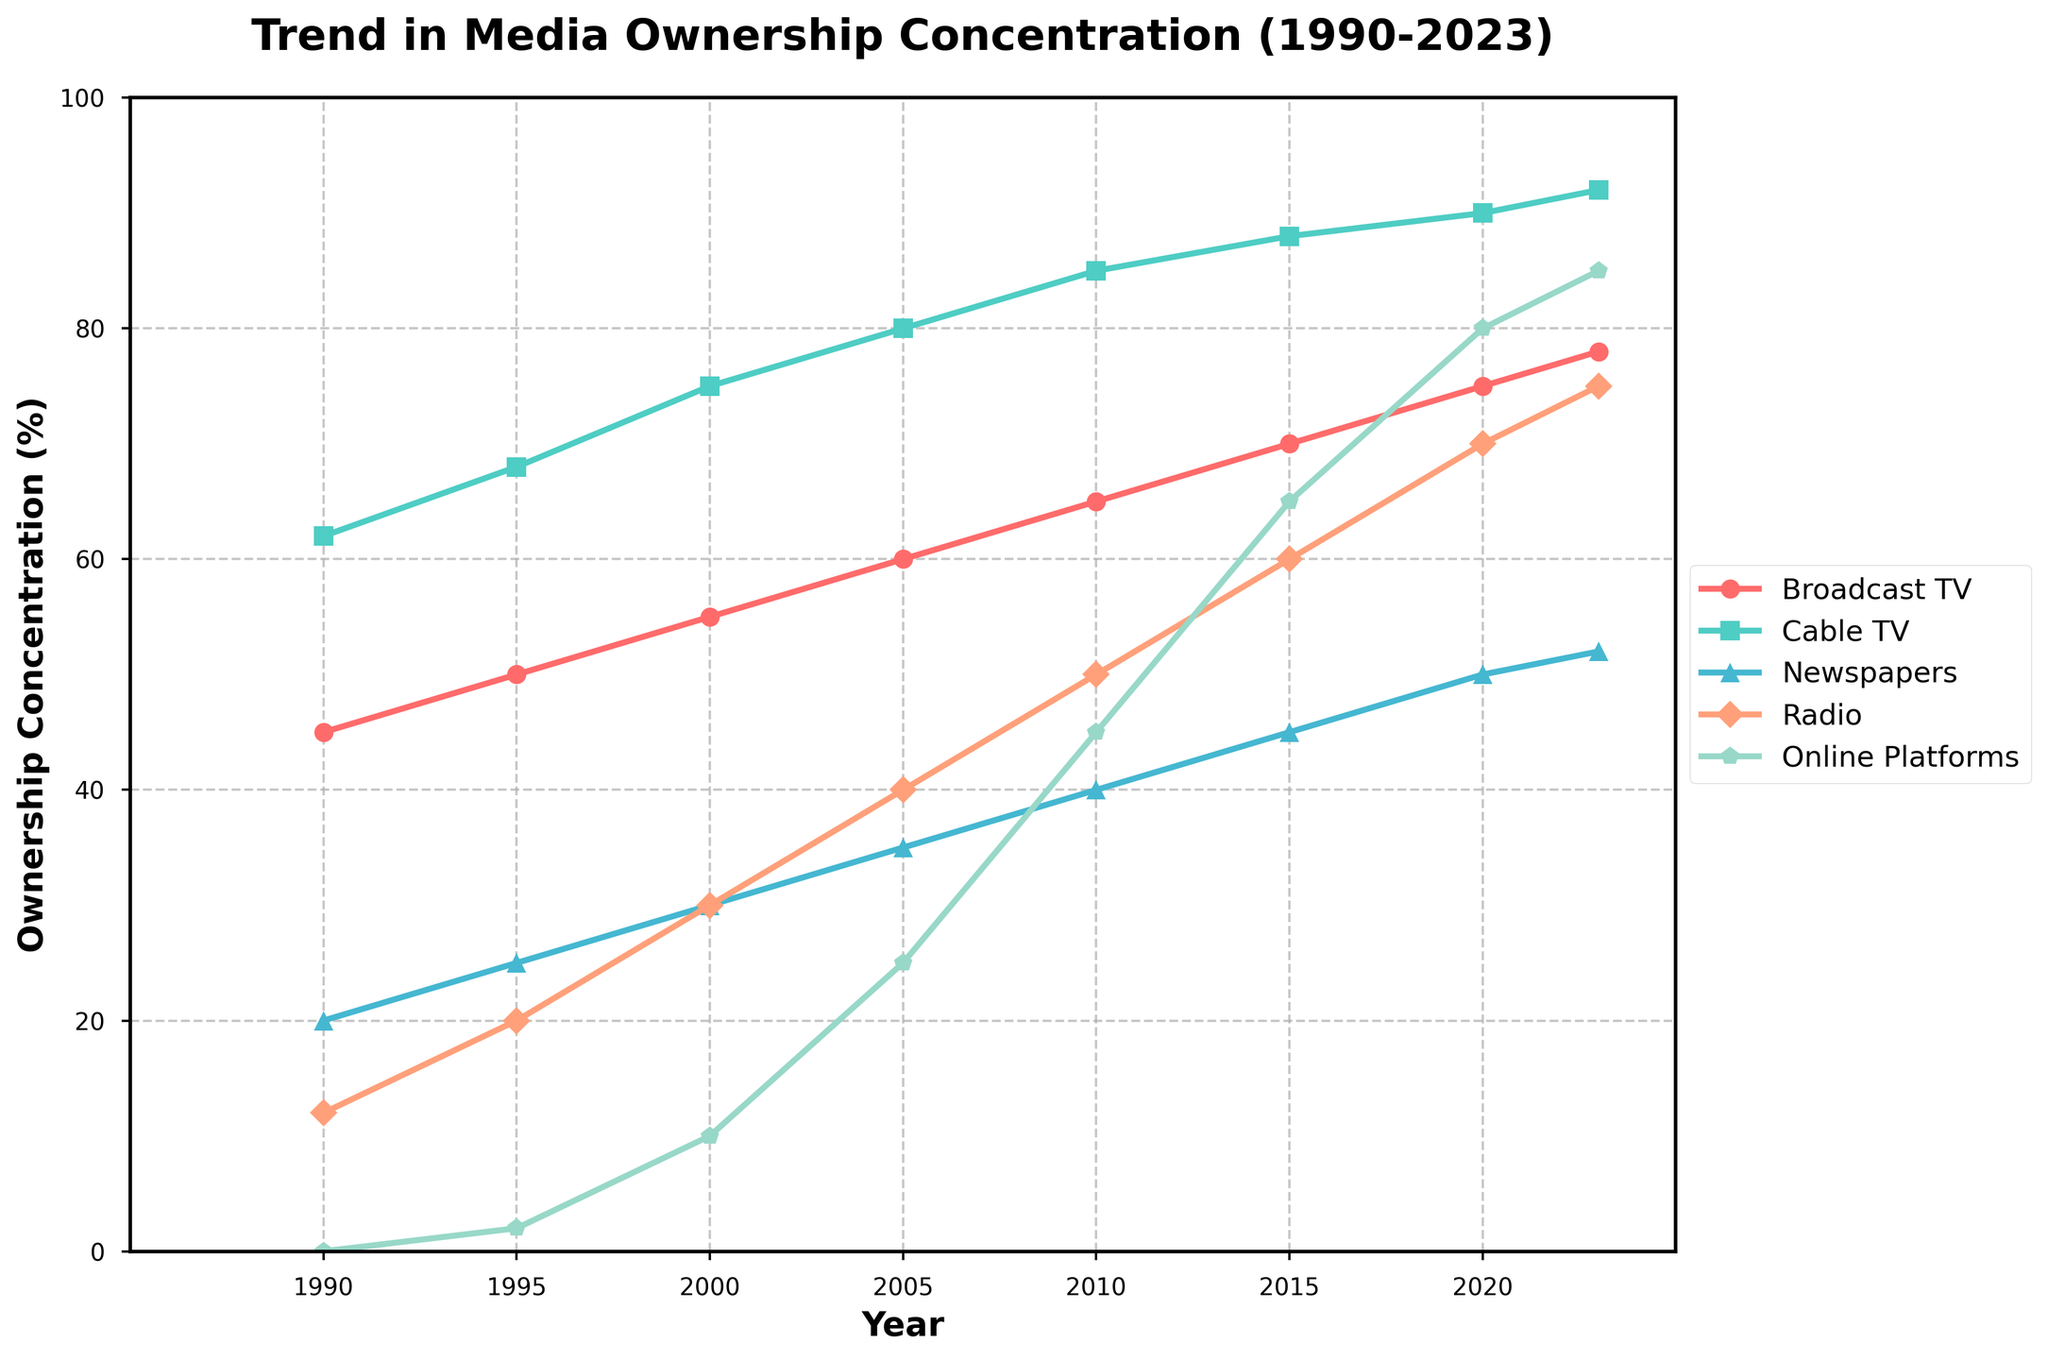what is the trend in broadcast TV ownership concentration between 1990 and 2023? The trend in broadcast TV shows an increase in ownership concentration. It starts at 45% in 1990 and gradually rises to 78% by 2023.
Answer: increasing Between which two periods did online platforms see the most significant increase in ownership concentration? To find the period with the most significant increase, calculate the yearly changes and identify the largest one. The largest increase is between 2000 and 2005, where the concentration jumped from 10% to 25%, an increase of 15%.
Answer: 2000-2005 What is the difference in ownership concentration between radio and newspapers in 2023? In 2023, the ownership concentration for radio is 75% and for newspapers is 52%. Subtracting the newspaper concentration from radio concentration, 75% - 52%, gives a difference of 23%.
Answer: 23% How does the ownership concentration of cable TV in 2020 compare to that of broadcast TV in 2005? The ownership concentration of cable TV in 2020 is 90%, while that of broadcast TV in 2005 is 60%. Comparing these values shows that cable TV in 2020 has a higher concentration than broadcast TV in 2005.
Answer: higher Which platform had the lowest ownership concentration in 1995, and what was its percentage? In 1995, radio had the lowest ownership concentration among all platforms, with a percentage of 20%.
Answer: radio, 20% By how much did the ownership concentration of newspapers increase from 1990 to 2023? The ownership concentration of newspapers increased from 20% in 1990 to 52% in 2023. The increase is calculated by subtracting the initial value from the final value: 52% - 20% = 32%.
Answer: 32% Which platform experienced a steady increase in ownership concentration without any drop over the years? Evaluating the trends from the figure, all the platforms (Broadcast TV, Cable TV, Newspapers, Radio, and Online Platforms) show a steady increase in ownership concentration without any drop.
Answer: all platforms What was the average ownership concentration of cable TV from 1990 to 2005? To find the average concentration of cable TV from 1990 to 2005, sum up the values for those years (62 + 68 + 75 + 80) and divide by the count of years: (62 + 68 + 75 + 80) / 4 = 285 / 4 = 71.25%.
Answer: 71.25% What is the trend in ownership concentration for online platforms between 2010 and 2023? The ownership concentration for online platforms shows a clear increasing trend between 2010 and 2023, starting at 45% in 2010 and rising to 85% in 2023.
Answer: increasing 